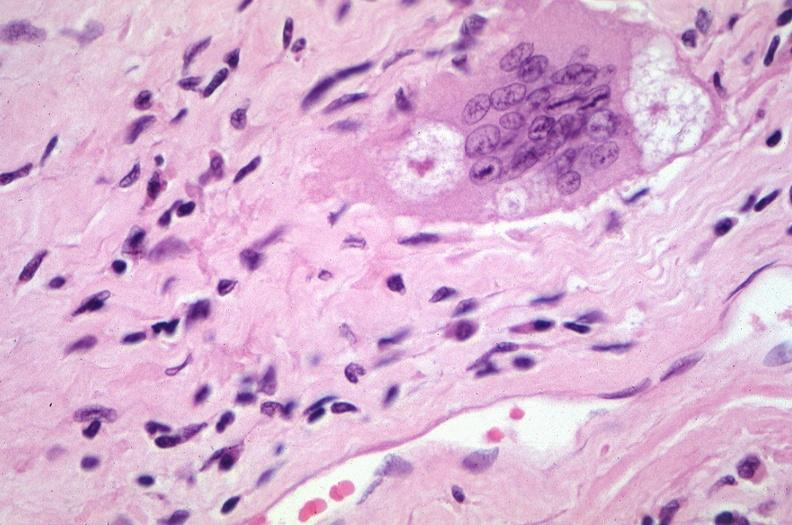does this image show lung, sarcoidosis, multinucleated giant cells with asteroid bodies?
Answer the question using a single word or phrase. Yes 